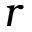Convert formula to latex. <formula><loc_0><loc_0><loc_500><loc_500>r</formula> 